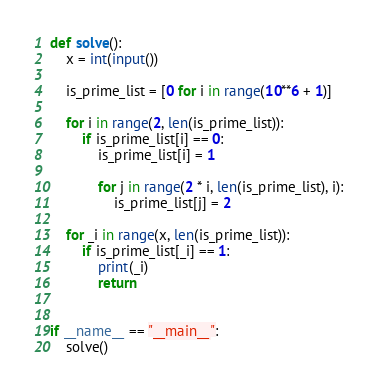Convert code to text. <code><loc_0><loc_0><loc_500><loc_500><_Python_>def solve():
    x = int(input())

    is_prime_list = [0 for i in range(10**6 + 1)]

    for i in range(2, len(is_prime_list)):
        if is_prime_list[i] == 0:
            is_prime_list[i] = 1
            
            for j in range(2 * i, len(is_prime_list), i):
                is_prime_list[j] = 2

    for _i in range(x, len(is_prime_list)):
        if is_prime_list[_i] == 1:
            print(_i)
            return


if __name__ == "__main__":
    solve()</code> 